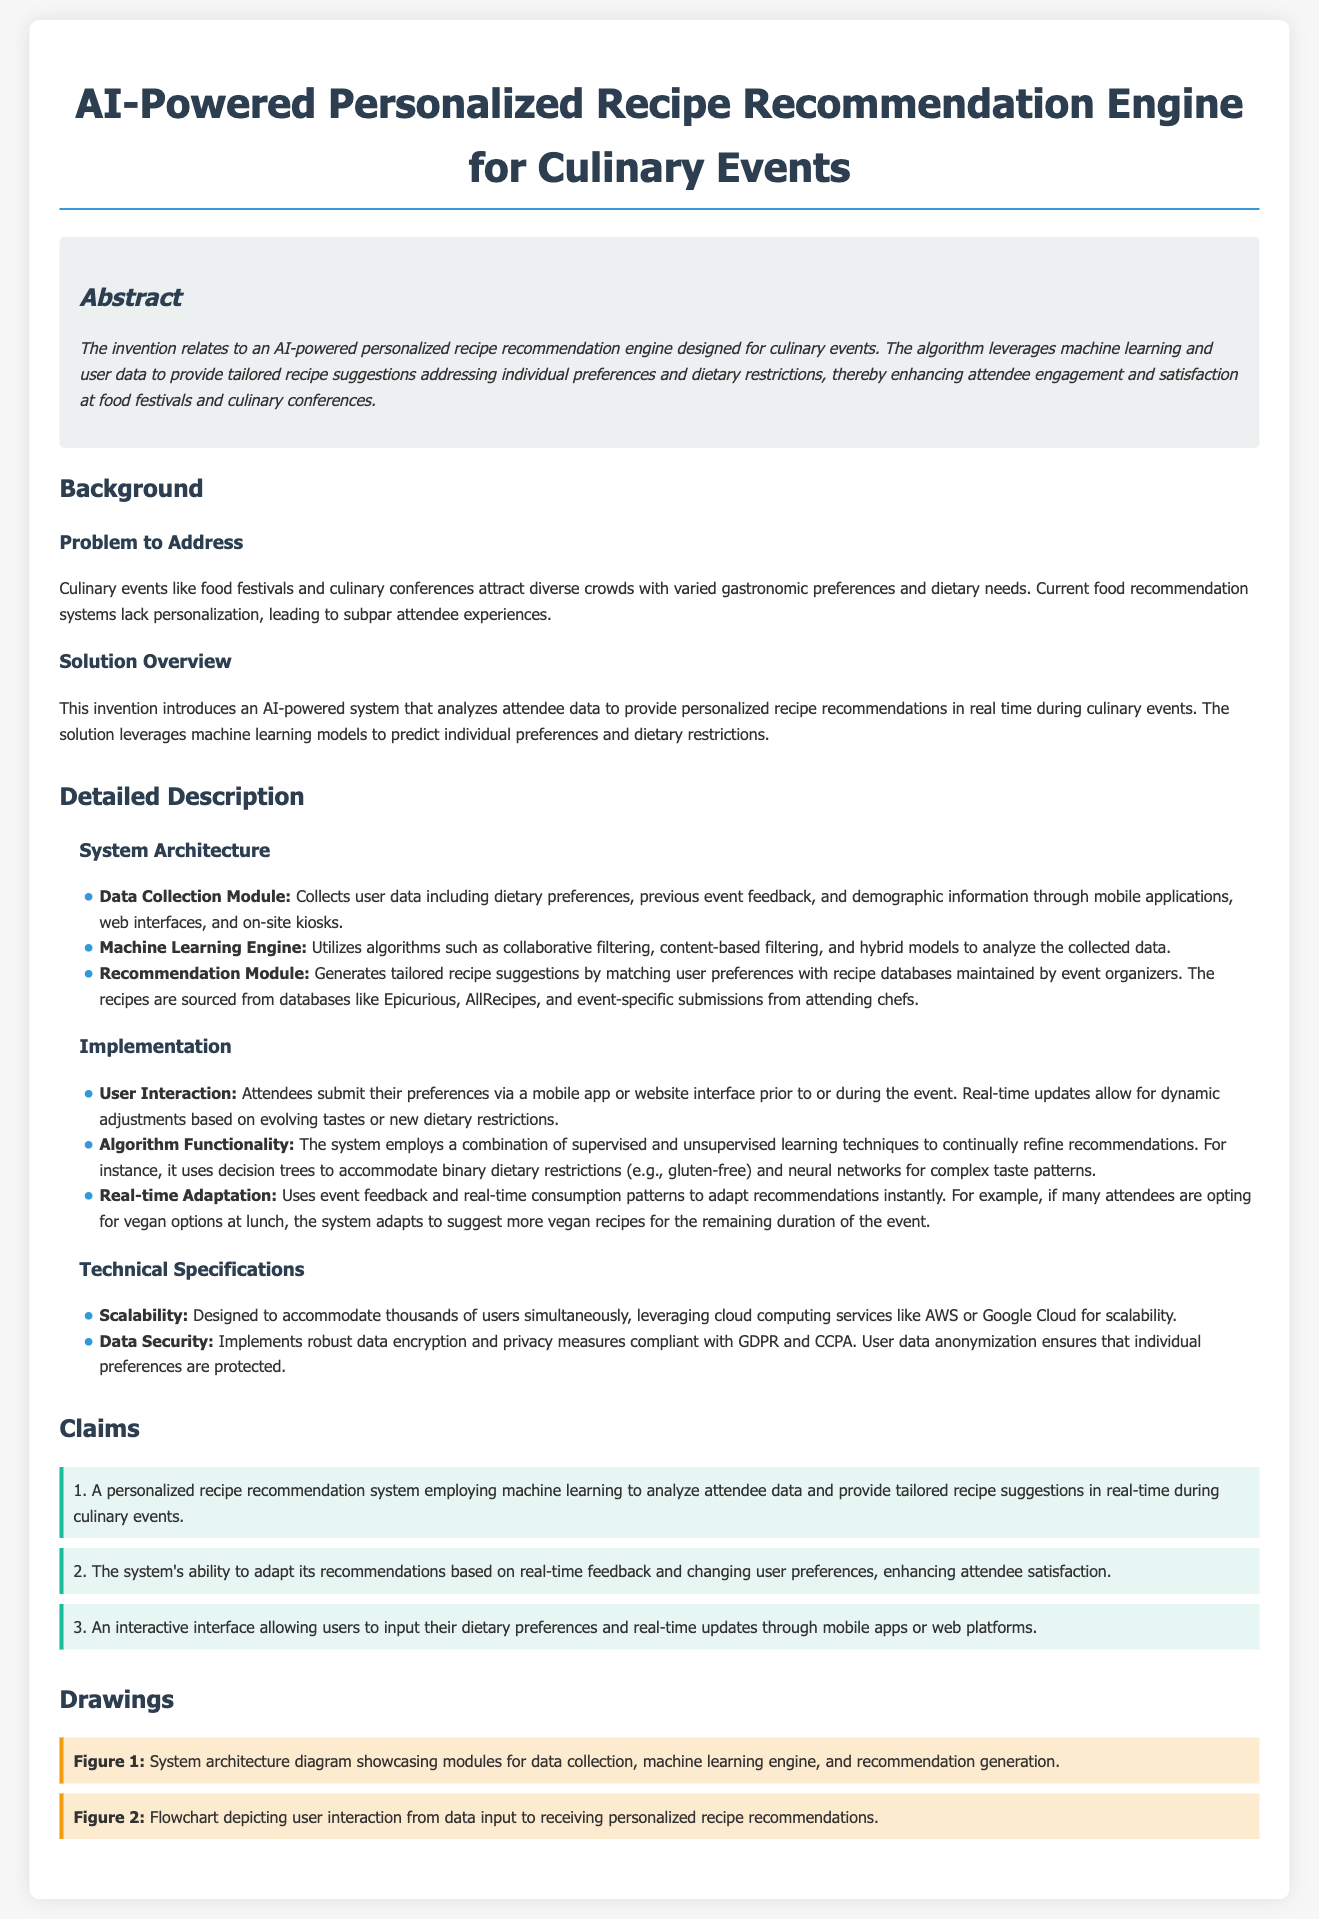What is the title of the patent application? The title of the patent application is stated clearly at the top of the document.
Answer: AI-Powered Personalized Recipe Recommendation Engine for Culinary Events What does the invention relate to? The document outlines that the invention relates to an AI-powered personalized recipe recommendation engine.
Answer: An AI-powered personalized recipe recommendation engine What is the primary problem addressed by the invention? The document specifies that current food recommendation systems lack personalization, leading to subpar attendee experiences.
Answer: Lack of personalization What types of modules are included in the system architecture? The document mentions several specific modules in the system architecture such as the Data Collection Module, Machine Learning Engine, and Recommendation Module.
Answer: Data Collection Module, Machine Learning Engine, Recommendation Module How does the system adapt its recommendations? The document describes that the system uses event feedback and real-time consumption patterns to adapt recommendations.
Answer: Event feedback and real-time consumption patterns Which cloud services are mentioned for scalability? It is stated in the documentation that the system can leverage cloud computing services like AWS or Google Cloud.
Answer: AWS or Google Cloud What are the two key compliance regulations mentioned for data security? The document highlights the importance of certain regulations related to privacy and data protection for user data.
Answer: GDPR and CCPA How many claims are presented in the patent application? A numbered list indicates the total number of claims made in the document.
Answer: Three claims What type of preferences can users input through the interactive interface? The document specifies that users can submit dietary preferences via the system’s interface.
Answer: Dietary preferences 